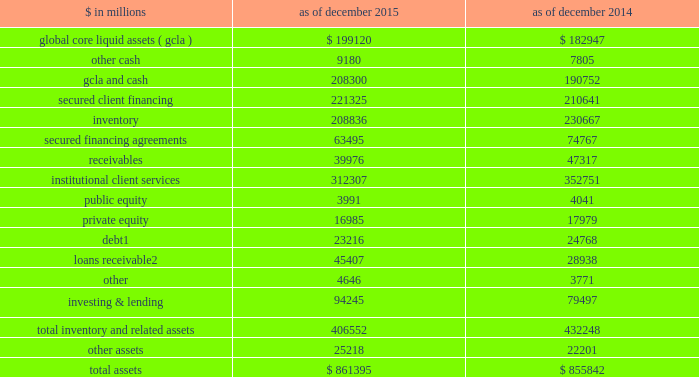The goldman sachs group , inc .
And subsidiaries management 2019s discussion and analysis scenario analyses .
We conduct various scenario analyses including as part of the comprehensive capital analysis and review ( ccar ) and dodd-frank act stress tests ( dfast ) , as well as our resolution and recovery planning .
See 201cequity capital management and regulatory capital 2014 equity capital management 201d below for further information .
These scenarios cover short-term and long- term time horizons using various macroeconomic and firm- specific assumptions , based on a range of economic scenarios .
We use these analyses to assist us in developing our longer-term balance sheet management strategy , including the level and composition of assets , funding and equity capital .
Additionally , these analyses help us develop approaches for maintaining appropriate funding , liquidity and capital across a variety of situations , including a severely stressed environment .
Balance sheet allocation in addition to preparing our consolidated statements of financial condition in accordance with u.s .
Gaap , we prepare a balance sheet that generally allocates assets to our businesses , which is a non-gaap presentation and may not be comparable to similar non-gaap presentations used by other companies .
We believe that presenting our assets on this basis is meaningful because it is consistent with the way management views and manages risks associated with the firm 2019s assets and better enables investors to assess the liquidity of the firm 2019s assets .
The table below presents our balance sheet allocation. .
Includes $ 17.29 billion and $ 18.24 billion as of december 2015 and december 2014 , respectively , of direct loans primarily extended to corporate and private wealth management clients that are accounted for at fair value .
See note 9 to the consolidated financial statements for further information about loans receivable .
The following is a description of the captions in the table above : 2030 global core liquid assets and cash .
We maintain liquidity to meet a broad range of potential cash outflows and collateral needs in a stressed environment .
See 201cliquidity risk management 201d below for details on the composition and sizing of our 201cglobal core liquid assets 201d ( gcla ) .
In addition to our gcla , we maintain other operating cash balances , primarily for use in specific currencies , entities , or jurisdictions where we do not have immediate access to parent company liquidity .
2030 secured client financing .
We provide collateralized financing for client positions , including margin loans secured by client collateral , securities borrowed , and resale agreements primarily collateralized by government obligations .
As a result of client activities , we are required to segregate cash and securities to satisfy regulatory requirements .
Our secured client financing arrangements , which are generally short-term , are accounted for at fair value or at amounts that approximate fair value , and include daily margin requirements to mitigate counterparty credit risk .
2030 institutional client services .
In institutional client services , we maintain inventory positions to facilitate market making in fixed income , equity , currency and commodity products .
Additionally , as part of market- making activities , we enter into resale or securities borrowing arrangements to obtain securities which we can use to cover transactions in which we or our clients have sold securities that have not yet been purchased .
The receivables in institutional client services primarily relate to securities transactions .
2030 investing & lending .
In investing & lending , we make investments and originate loans to provide financing to clients .
These investments and loans are typically longer- term in nature .
We make investments , directly and indirectly through funds and separate accounts that we manage , in debt securities , loans , public and private equity securities , real estate entities and other investments .
2030 other assets .
Other assets are generally less liquid , non- financial assets , including property , leasehold improvements and equipment , goodwill and identifiable intangible assets , income tax-related receivables , equity- method investments , assets classified as held for sale and miscellaneous receivables .
68 goldman sachs 2015 form 10-k .
How is cash flow from operating activities affected by the change in inventory from 2014 to 2015? 
Computations: (230667 - 208836)
Answer: 21831.0. 